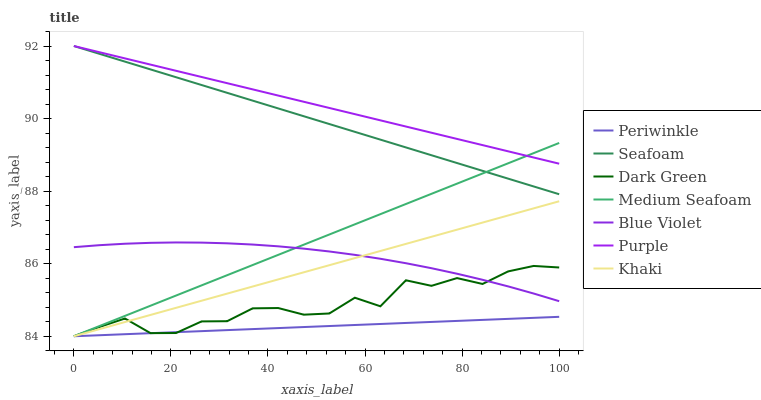Does Seafoam have the minimum area under the curve?
Answer yes or no. No. Does Seafoam have the maximum area under the curve?
Answer yes or no. No. Is Purple the smoothest?
Answer yes or no. No. Is Purple the roughest?
Answer yes or no. No. Does Seafoam have the lowest value?
Answer yes or no. No. Does Periwinkle have the highest value?
Answer yes or no. No. Is Blue Violet less than Seafoam?
Answer yes or no. Yes. Is Seafoam greater than Khaki?
Answer yes or no. Yes. Does Blue Violet intersect Seafoam?
Answer yes or no. No. 